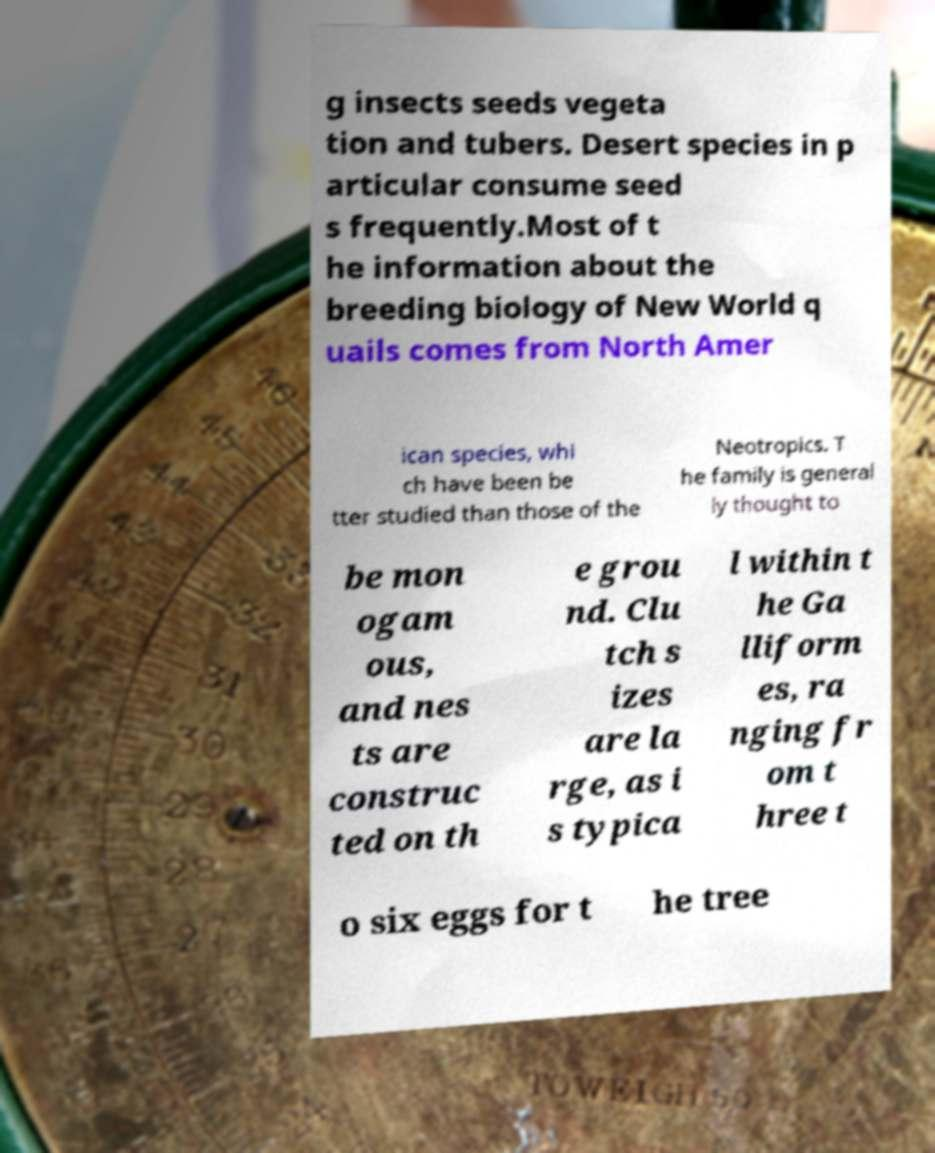For documentation purposes, I need the text within this image transcribed. Could you provide that? g insects seeds vegeta tion and tubers. Desert species in p articular consume seed s frequently.Most of t he information about the breeding biology of New World q uails comes from North Amer ican species, whi ch have been be tter studied than those of the Neotropics. T he family is general ly thought to be mon ogam ous, and nes ts are construc ted on th e grou nd. Clu tch s izes are la rge, as i s typica l within t he Ga lliform es, ra nging fr om t hree t o six eggs for t he tree 